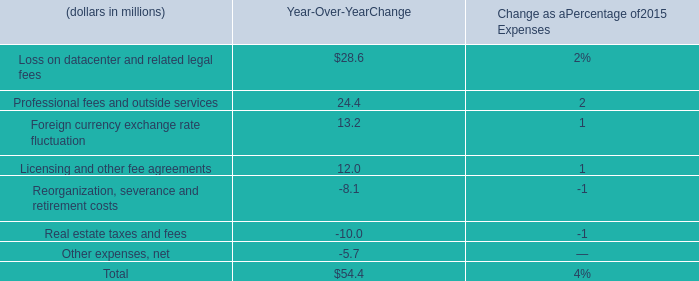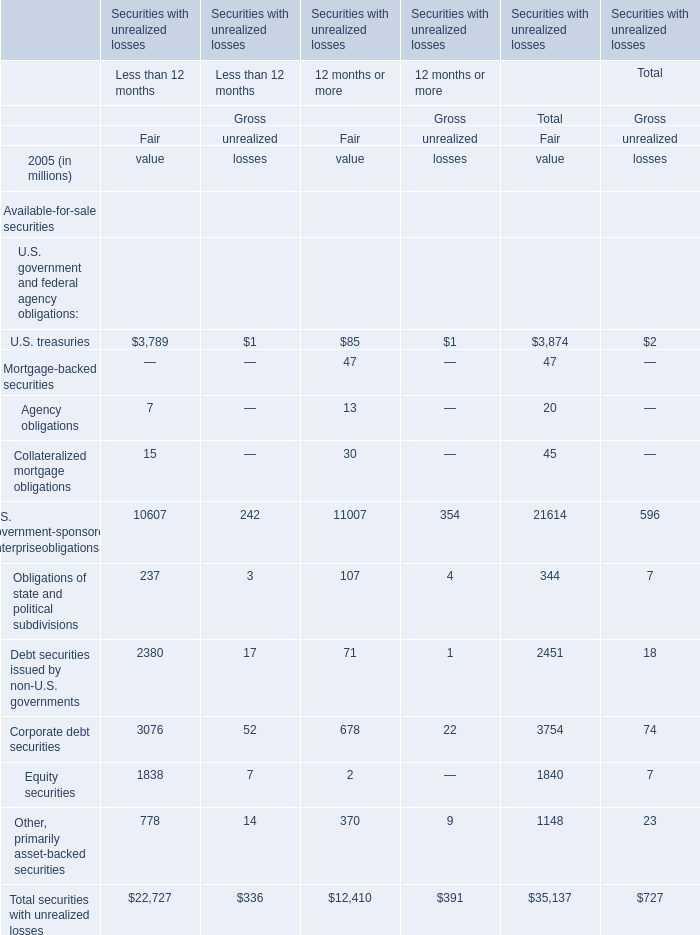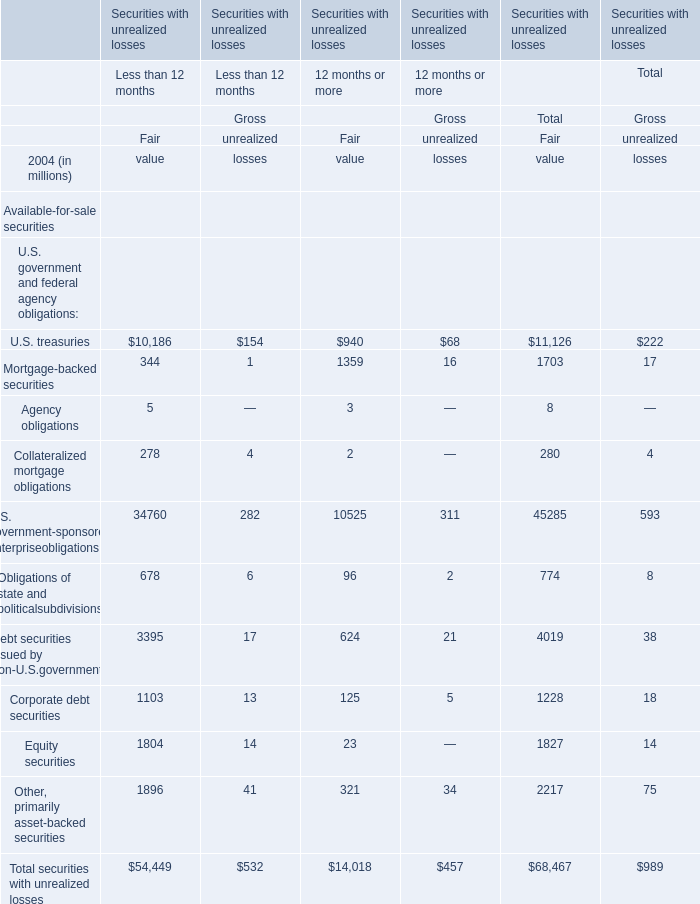Which element for Fair value of Total exceeds 10 % of total in 2005? 
Answer: U.S. treasuries, U.S. government-sponsored enterpriseobligations,Corporate debt securities. 